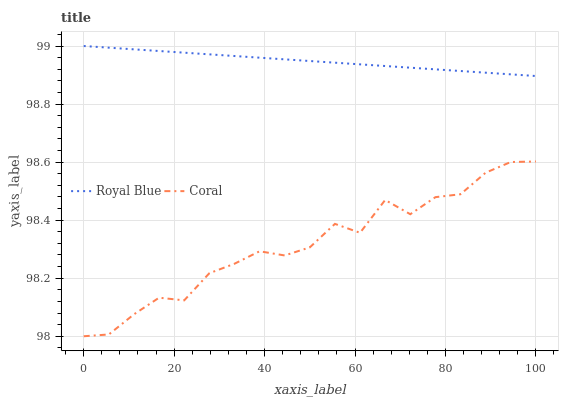Does Coral have the minimum area under the curve?
Answer yes or no. Yes. Does Royal Blue have the maximum area under the curve?
Answer yes or no. Yes. Does Coral have the maximum area under the curve?
Answer yes or no. No. Is Royal Blue the smoothest?
Answer yes or no. Yes. Is Coral the roughest?
Answer yes or no. Yes. Is Coral the smoothest?
Answer yes or no. No. Does Coral have the lowest value?
Answer yes or no. Yes. Does Royal Blue have the highest value?
Answer yes or no. Yes. Does Coral have the highest value?
Answer yes or no. No. Is Coral less than Royal Blue?
Answer yes or no. Yes. Is Royal Blue greater than Coral?
Answer yes or no. Yes. Does Coral intersect Royal Blue?
Answer yes or no. No. 